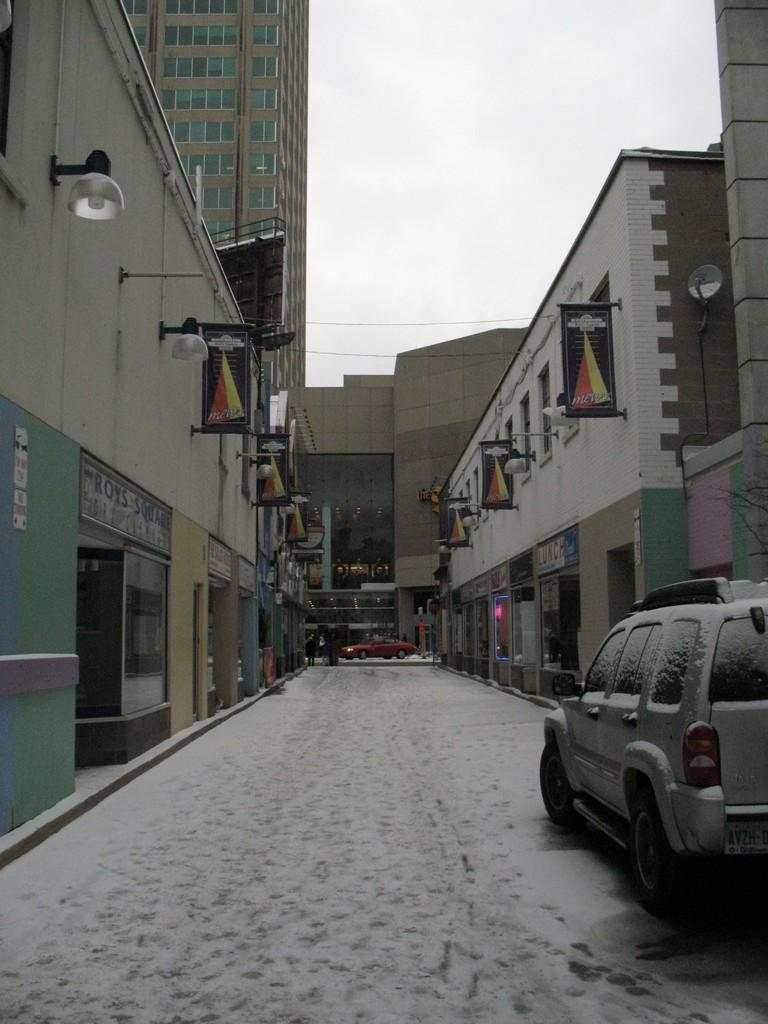What is the main feature in the middle of the image? There is a path in the middle of the image. What can be seen traveling on the path? There are vehicles on the path. What type of structures are located on both sides of the path? There are buildings on both sides of the path. How would you describe the sky in the image? The sky is clear in the image. How many daughters can be seen playing with balls in the image? There are no daughters or balls present in the image. What type of birds are flying above the buildings in the image? There are no birds visible in the image; only the path, vehicles, buildings, and clear sky are present. 